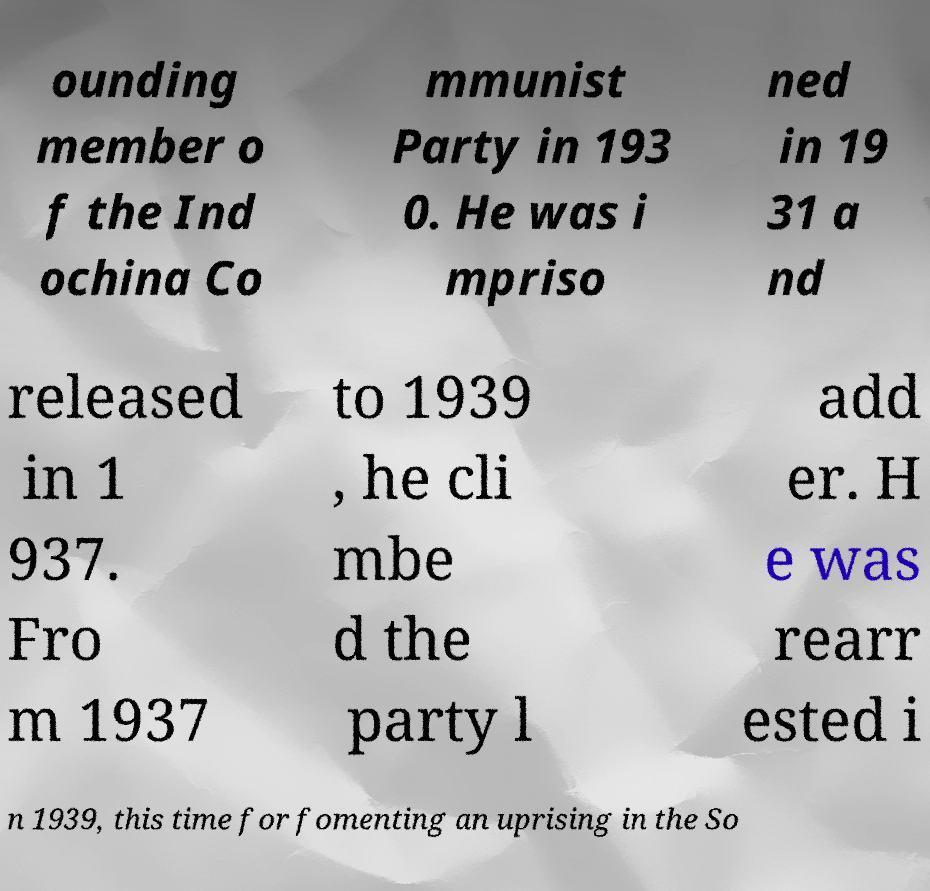Can you accurately transcribe the text from the provided image for me? ounding member o f the Ind ochina Co mmunist Party in 193 0. He was i mpriso ned in 19 31 a nd released in 1 937. Fro m 1937 to 1939 , he cli mbe d the party l add er. H e was rearr ested i n 1939, this time for fomenting an uprising in the So 